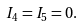Convert formula to latex. <formula><loc_0><loc_0><loc_500><loc_500>I _ { 4 } = I _ { 5 } = 0 .</formula> 